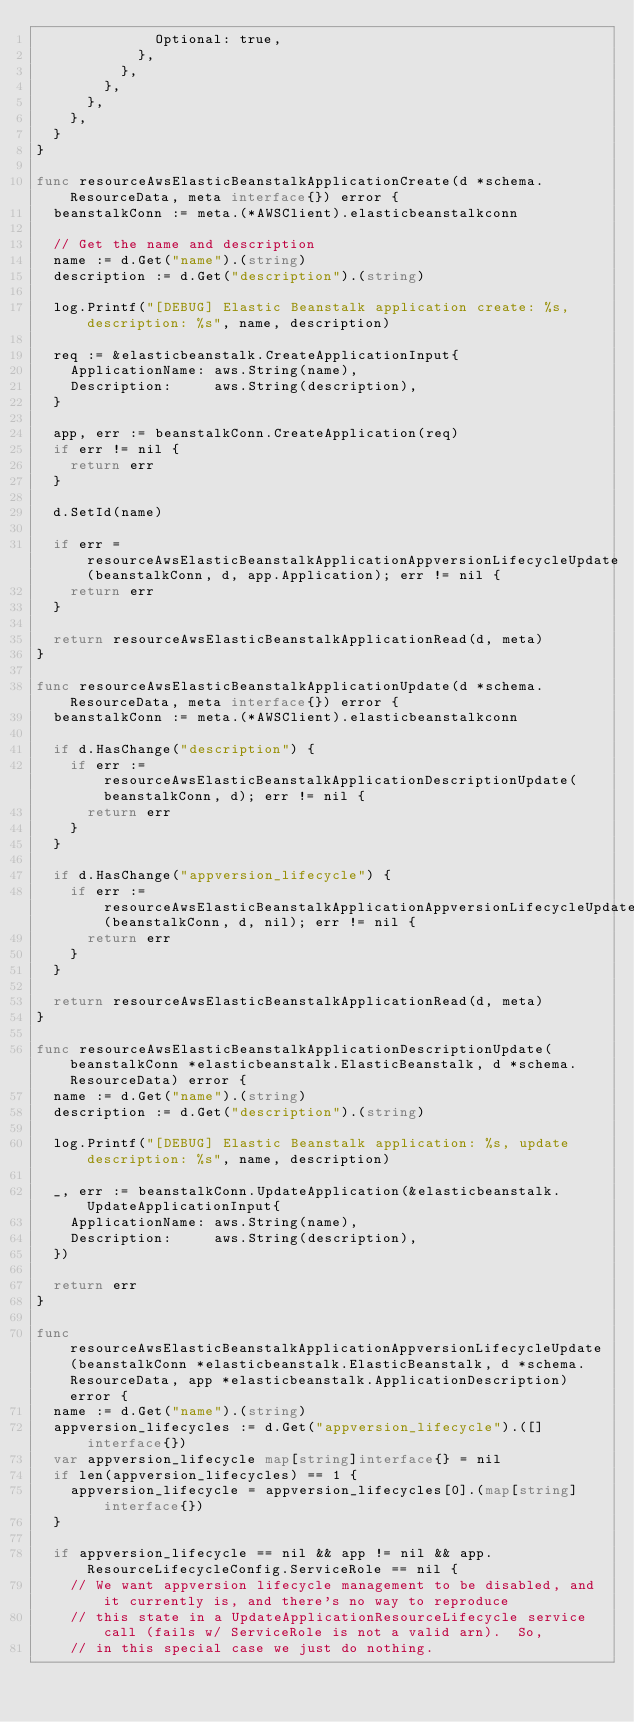Convert code to text. <code><loc_0><loc_0><loc_500><loc_500><_Go_>							Optional: true,
						},
					},
				},
			},
		},
	}
}

func resourceAwsElasticBeanstalkApplicationCreate(d *schema.ResourceData, meta interface{}) error {
	beanstalkConn := meta.(*AWSClient).elasticbeanstalkconn

	// Get the name and description
	name := d.Get("name").(string)
	description := d.Get("description").(string)

	log.Printf("[DEBUG] Elastic Beanstalk application create: %s, description: %s", name, description)

	req := &elasticbeanstalk.CreateApplicationInput{
		ApplicationName: aws.String(name),
		Description:     aws.String(description),
	}

	app, err := beanstalkConn.CreateApplication(req)
	if err != nil {
		return err
	}

	d.SetId(name)

	if err = resourceAwsElasticBeanstalkApplicationAppversionLifecycleUpdate(beanstalkConn, d, app.Application); err != nil {
		return err
	}

	return resourceAwsElasticBeanstalkApplicationRead(d, meta)
}

func resourceAwsElasticBeanstalkApplicationUpdate(d *schema.ResourceData, meta interface{}) error {
	beanstalkConn := meta.(*AWSClient).elasticbeanstalkconn

	if d.HasChange("description") {
		if err := resourceAwsElasticBeanstalkApplicationDescriptionUpdate(beanstalkConn, d); err != nil {
			return err
		}
	}

	if d.HasChange("appversion_lifecycle") {
		if err := resourceAwsElasticBeanstalkApplicationAppversionLifecycleUpdate(beanstalkConn, d, nil); err != nil {
			return err
		}
	}

	return resourceAwsElasticBeanstalkApplicationRead(d, meta)
}

func resourceAwsElasticBeanstalkApplicationDescriptionUpdate(beanstalkConn *elasticbeanstalk.ElasticBeanstalk, d *schema.ResourceData) error {
	name := d.Get("name").(string)
	description := d.Get("description").(string)

	log.Printf("[DEBUG] Elastic Beanstalk application: %s, update description: %s", name, description)

	_, err := beanstalkConn.UpdateApplication(&elasticbeanstalk.UpdateApplicationInput{
		ApplicationName: aws.String(name),
		Description:     aws.String(description),
	})

	return err
}

func resourceAwsElasticBeanstalkApplicationAppversionLifecycleUpdate(beanstalkConn *elasticbeanstalk.ElasticBeanstalk, d *schema.ResourceData, app *elasticbeanstalk.ApplicationDescription) error {
	name := d.Get("name").(string)
	appversion_lifecycles := d.Get("appversion_lifecycle").([]interface{})
	var appversion_lifecycle map[string]interface{} = nil
	if len(appversion_lifecycles) == 1 {
		appversion_lifecycle = appversion_lifecycles[0].(map[string]interface{})
	}

	if appversion_lifecycle == nil && app != nil && app.ResourceLifecycleConfig.ServiceRole == nil {
		// We want appversion lifecycle management to be disabled, and it currently is, and there's no way to reproduce
		// this state in a UpdateApplicationResourceLifecycle service call (fails w/ ServiceRole is not a valid arn).  So,
		// in this special case we just do nothing.</code> 